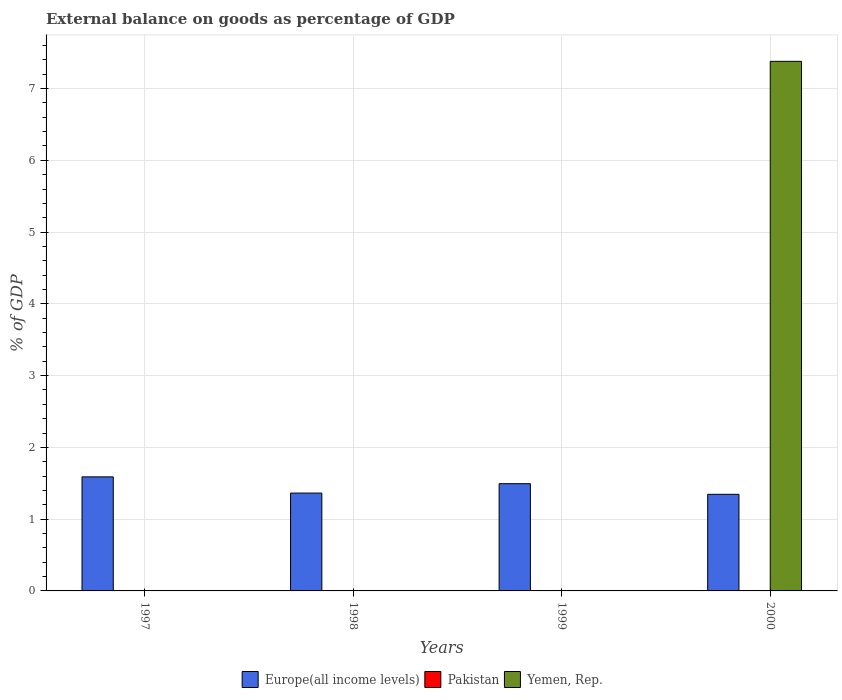How many different coloured bars are there?
Provide a short and direct response. 2. Are the number of bars per tick equal to the number of legend labels?
Offer a very short reply. No. How many bars are there on the 2nd tick from the right?
Your answer should be compact. 1. In how many cases, is the number of bars for a given year not equal to the number of legend labels?
Give a very brief answer. 4. What is the external balance on goods as percentage of GDP in Yemen, Rep. in 2000?
Give a very brief answer. 7.38. Across all years, what is the maximum external balance on goods as percentage of GDP in Europe(all income levels)?
Provide a short and direct response. 1.59. Across all years, what is the minimum external balance on goods as percentage of GDP in Yemen, Rep.?
Provide a short and direct response. 0. In which year was the external balance on goods as percentage of GDP in Yemen, Rep. maximum?
Give a very brief answer. 2000. What is the difference between the external balance on goods as percentage of GDP in Europe(all income levels) in 1997 and that in 1999?
Provide a short and direct response. 0.1. What is the difference between the external balance on goods as percentage of GDP in Yemen, Rep. in 2000 and the external balance on goods as percentage of GDP in Pakistan in 1999?
Your response must be concise. 7.38. What is the average external balance on goods as percentage of GDP in Yemen, Rep. per year?
Your response must be concise. 1.84. In the year 2000, what is the difference between the external balance on goods as percentage of GDP in Europe(all income levels) and external balance on goods as percentage of GDP in Yemen, Rep.?
Offer a terse response. -6.03. What is the difference between the highest and the second highest external balance on goods as percentage of GDP in Europe(all income levels)?
Your answer should be very brief. 0.1. What is the difference between the highest and the lowest external balance on goods as percentage of GDP in Yemen, Rep.?
Give a very brief answer. 7.38. In how many years, is the external balance on goods as percentage of GDP in Yemen, Rep. greater than the average external balance on goods as percentage of GDP in Yemen, Rep. taken over all years?
Offer a terse response. 1. Is it the case that in every year, the sum of the external balance on goods as percentage of GDP in Pakistan and external balance on goods as percentage of GDP in Europe(all income levels) is greater than the external balance on goods as percentage of GDP in Yemen, Rep.?
Offer a very short reply. No. How many bars are there?
Your response must be concise. 5. How many years are there in the graph?
Give a very brief answer. 4. What is the difference between two consecutive major ticks on the Y-axis?
Offer a very short reply. 1. Does the graph contain any zero values?
Offer a terse response. Yes. Where does the legend appear in the graph?
Provide a short and direct response. Bottom center. How many legend labels are there?
Make the answer very short. 3. What is the title of the graph?
Provide a short and direct response. External balance on goods as percentage of GDP. What is the label or title of the Y-axis?
Ensure brevity in your answer.  % of GDP. What is the % of GDP in Europe(all income levels) in 1997?
Ensure brevity in your answer.  1.59. What is the % of GDP in Pakistan in 1997?
Your answer should be compact. 0. What is the % of GDP in Europe(all income levels) in 1998?
Your response must be concise. 1.36. What is the % of GDP of Europe(all income levels) in 1999?
Provide a succinct answer. 1.49. What is the % of GDP in Europe(all income levels) in 2000?
Provide a short and direct response. 1.35. What is the % of GDP in Pakistan in 2000?
Your response must be concise. 0. What is the % of GDP of Yemen, Rep. in 2000?
Ensure brevity in your answer.  7.38. Across all years, what is the maximum % of GDP of Europe(all income levels)?
Provide a short and direct response. 1.59. Across all years, what is the maximum % of GDP of Yemen, Rep.?
Ensure brevity in your answer.  7.38. Across all years, what is the minimum % of GDP in Europe(all income levels)?
Offer a very short reply. 1.35. Across all years, what is the minimum % of GDP of Yemen, Rep.?
Provide a short and direct response. 0. What is the total % of GDP in Europe(all income levels) in the graph?
Offer a terse response. 5.79. What is the total % of GDP of Pakistan in the graph?
Make the answer very short. 0. What is the total % of GDP of Yemen, Rep. in the graph?
Make the answer very short. 7.38. What is the difference between the % of GDP in Europe(all income levels) in 1997 and that in 1998?
Make the answer very short. 0.23. What is the difference between the % of GDP in Europe(all income levels) in 1997 and that in 1999?
Give a very brief answer. 0.1. What is the difference between the % of GDP in Europe(all income levels) in 1997 and that in 2000?
Ensure brevity in your answer.  0.24. What is the difference between the % of GDP in Europe(all income levels) in 1998 and that in 1999?
Ensure brevity in your answer.  -0.13. What is the difference between the % of GDP in Europe(all income levels) in 1998 and that in 2000?
Offer a terse response. 0.02. What is the difference between the % of GDP of Europe(all income levels) in 1999 and that in 2000?
Your answer should be compact. 0.15. What is the difference between the % of GDP of Europe(all income levels) in 1997 and the % of GDP of Yemen, Rep. in 2000?
Your response must be concise. -5.79. What is the difference between the % of GDP of Europe(all income levels) in 1998 and the % of GDP of Yemen, Rep. in 2000?
Provide a succinct answer. -6.02. What is the difference between the % of GDP in Europe(all income levels) in 1999 and the % of GDP in Yemen, Rep. in 2000?
Ensure brevity in your answer.  -5.88. What is the average % of GDP of Europe(all income levels) per year?
Your answer should be compact. 1.45. What is the average % of GDP of Pakistan per year?
Your response must be concise. 0. What is the average % of GDP of Yemen, Rep. per year?
Your response must be concise. 1.84. In the year 2000, what is the difference between the % of GDP of Europe(all income levels) and % of GDP of Yemen, Rep.?
Keep it short and to the point. -6.03. What is the ratio of the % of GDP in Europe(all income levels) in 1997 to that in 1998?
Your answer should be compact. 1.17. What is the ratio of the % of GDP of Europe(all income levels) in 1997 to that in 1999?
Offer a very short reply. 1.06. What is the ratio of the % of GDP in Europe(all income levels) in 1997 to that in 2000?
Your answer should be very brief. 1.18. What is the ratio of the % of GDP in Europe(all income levels) in 1998 to that in 1999?
Offer a very short reply. 0.91. What is the ratio of the % of GDP in Europe(all income levels) in 1998 to that in 2000?
Offer a terse response. 1.01. What is the ratio of the % of GDP in Europe(all income levels) in 1999 to that in 2000?
Provide a succinct answer. 1.11. What is the difference between the highest and the second highest % of GDP of Europe(all income levels)?
Your answer should be very brief. 0.1. What is the difference between the highest and the lowest % of GDP in Europe(all income levels)?
Ensure brevity in your answer.  0.24. What is the difference between the highest and the lowest % of GDP of Yemen, Rep.?
Keep it short and to the point. 7.38. 